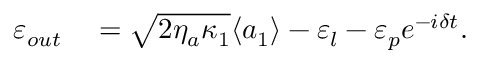Convert formula to latex. <formula><loc_0><loc_0><loc_500><loc_500>\begin{array} { r l } { \varepsilon _ { o u t } } & = \sqrt { 2 \eta _ { a } \kappa _ { 1 } } \langle a _ { 1 } \rangle - \varepsilon _ { l } - \varepsilon _ { p } e ^ { - i \delta t } . } \end{array}</formula> 